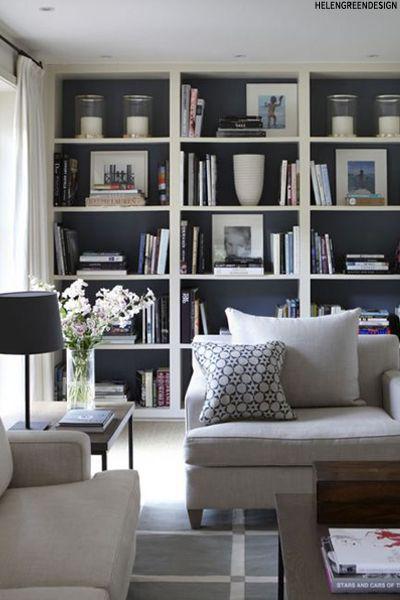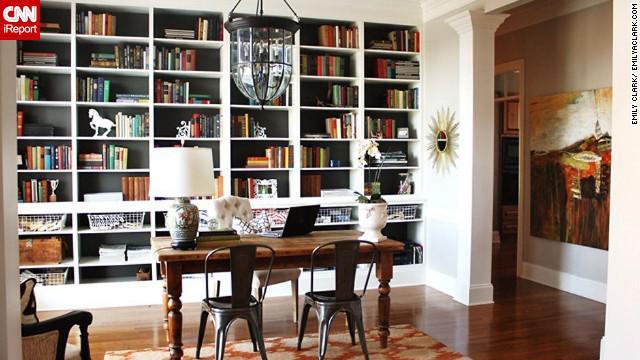The first image is the image on the left, the second image is the image on the right. Given the left and right images, does the statement "A ceiling lamp that hangs over a room is glass-like." hold true? Answer yes or no. Yes. The first image is the image on the left, the second image is the image on the right. Considering the images on both sides, is "A green plant with fanning leaves is near a backless and sideless set of vertical shelves." valid? Answer yes or no. No. 